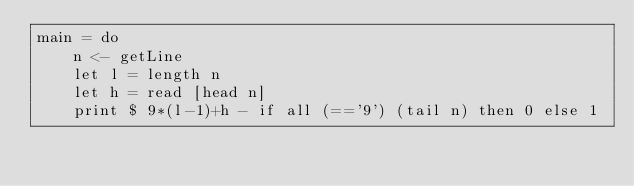<code> <loc_0><loc_0><loc_500><loc_500><_Haskell_>main = do
    n <- getLine
    let l = length n
    let h = read [head n]
    print $ 9*(l-1)+h - if all (=='9') (tail n) then 0 else 1</code> 